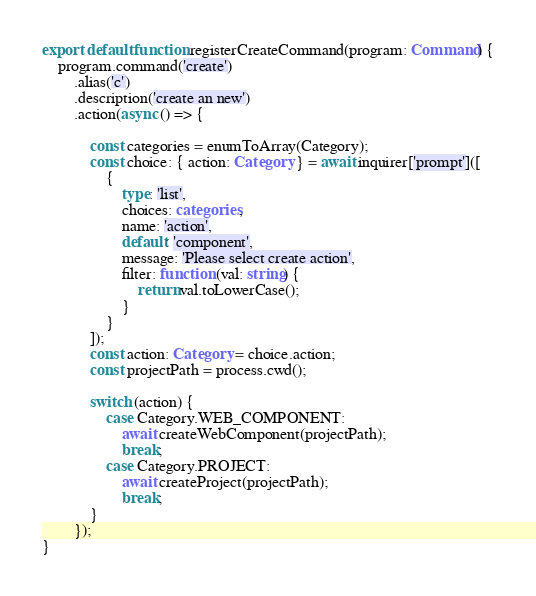Convert code to text. <code><loc_0><loc_0><loc_500><loc_500><_TypeScript_>
export default function registerCreateCommand(program: Command) {
    program.command('create')
        .alias('c')
        .description('create an new')
        .action(async () => {

            const categories = enumToArray(Category);
            const choice: { action: Category } = await inquirer['prompt']([
                {
                    type: 'list',
                    choices: categories,
                    name: 'action',
                    default: 'component',
                    message: 'Please select create action',
                    filter: function (val: string) {
                        return val.toLowerCase();
                    }
                }
            ]);
            const action: Category = choice.action;
            const projectPath = process.cwd();

            switch (action) {
                case Category.WEB_COMPONENT:
                    await createWebComponent(projectPath);
                    break;
                case Category.PROJECT:
                    await createProject(projectPath);
                    break;
            }
        });
}
</code> 